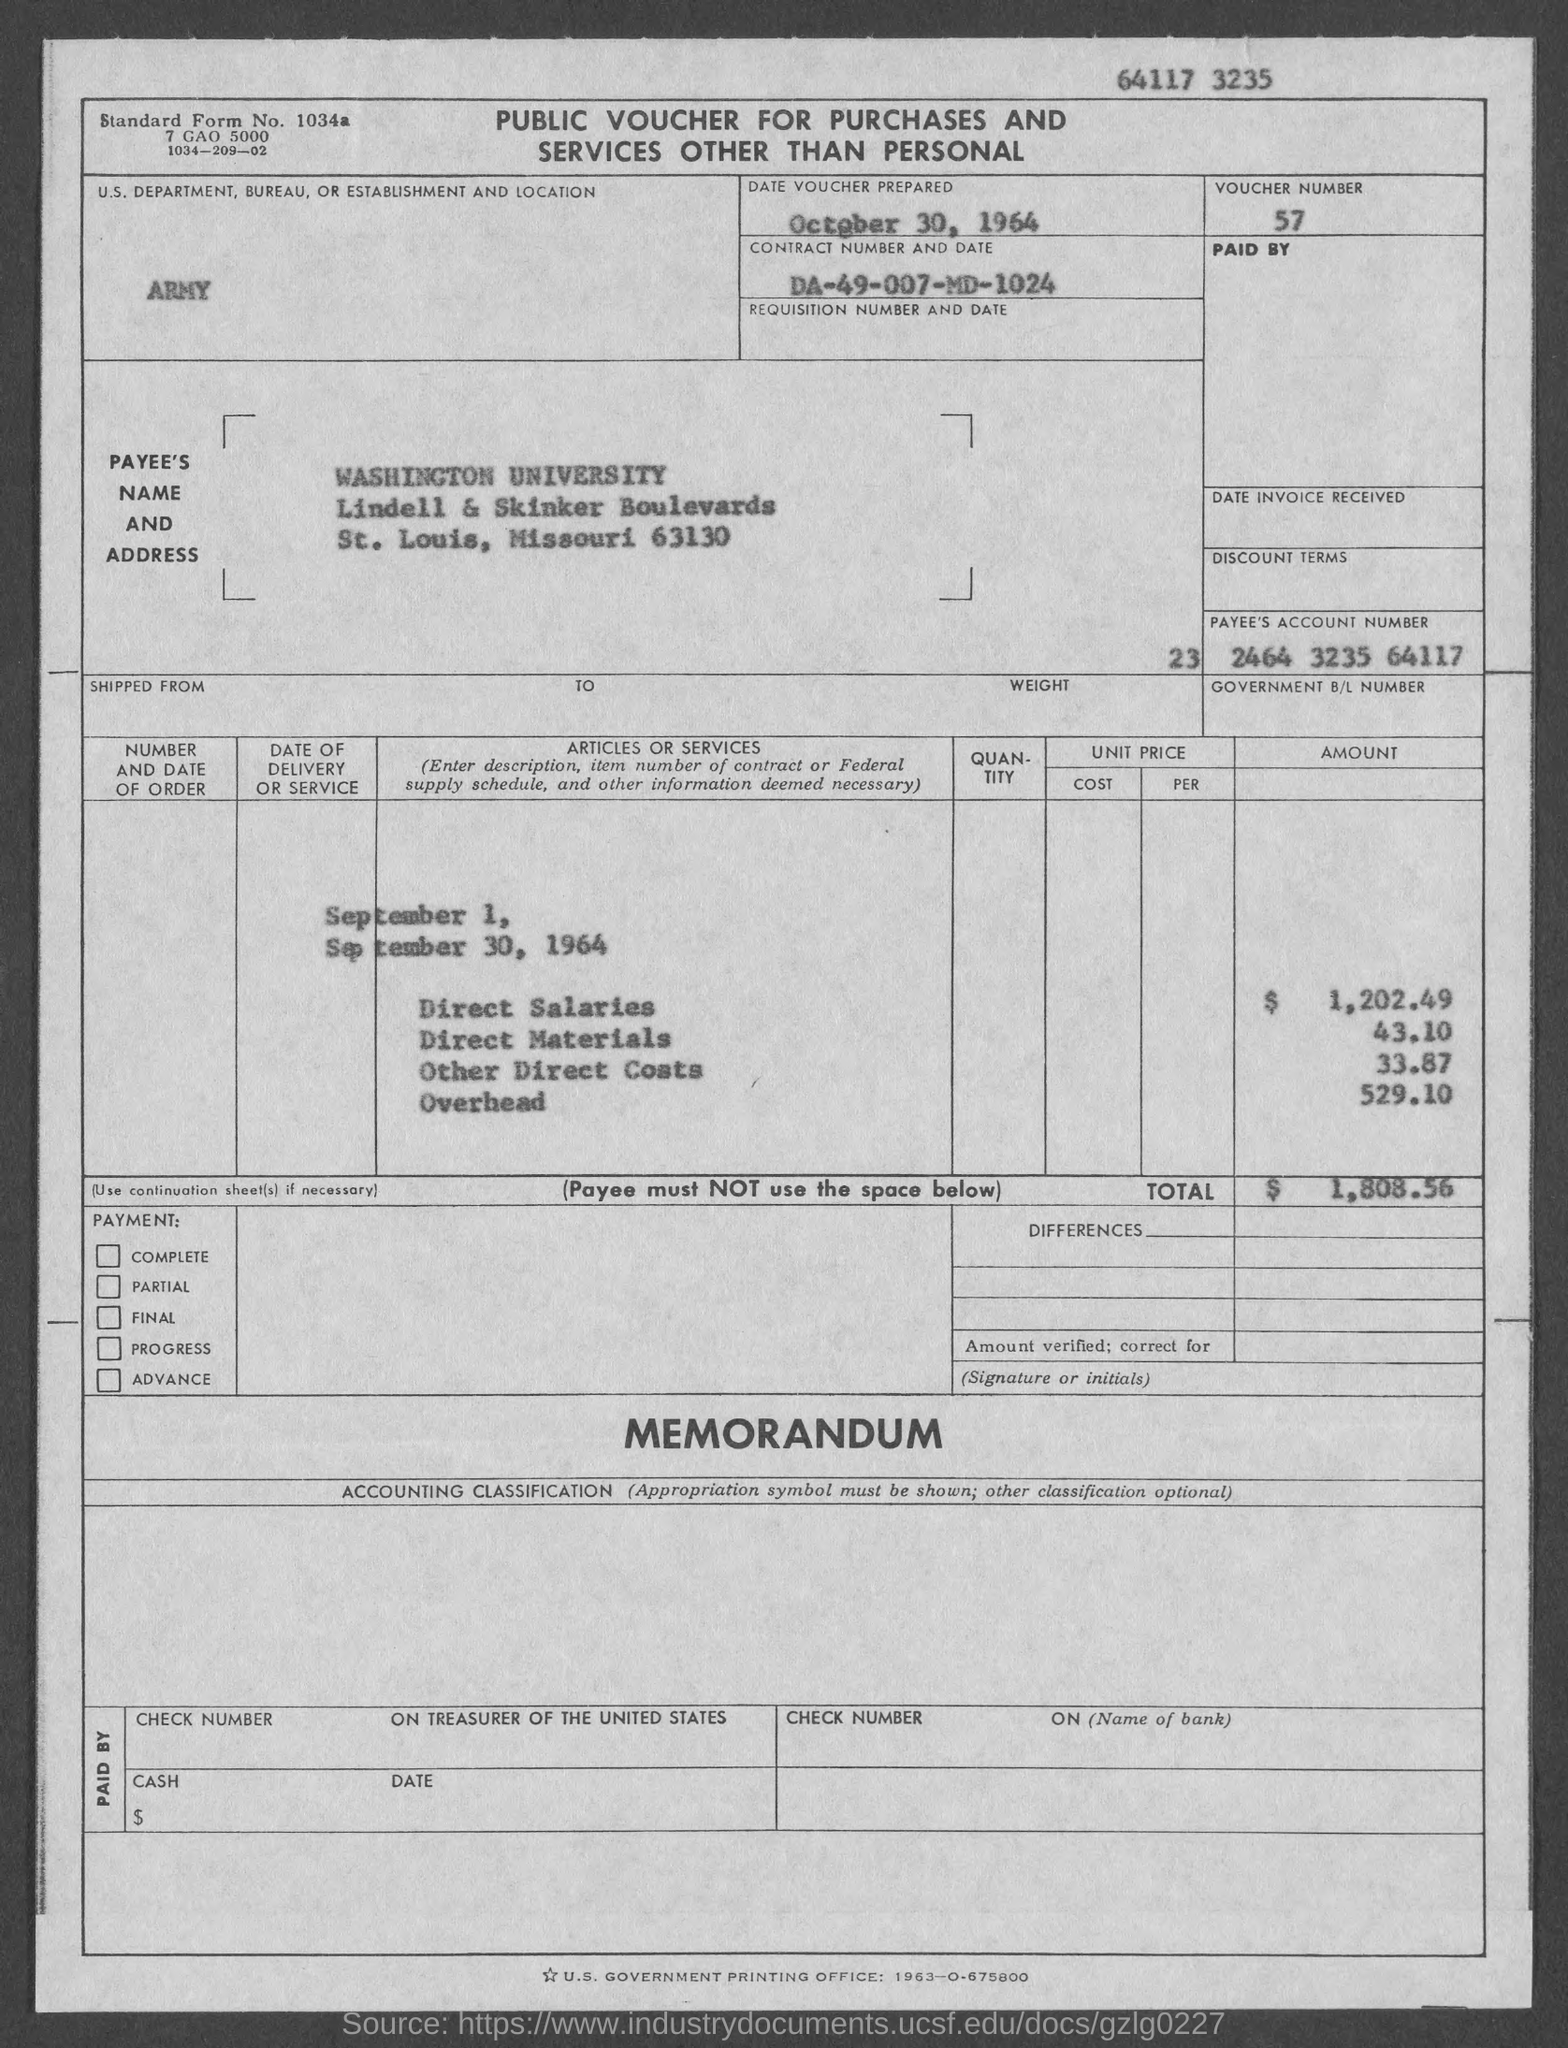What is the voucher no.?
Provide a succinct answer. 57. When is the date voucher is  prepared ?
Your answer should be compact. October 30, 1964. What is the standard form no.?
Keep it short and to the point. 1034a. What is the total amount ?
Give a very brief answer. $1,808.56. What is the us. department, bureau, or establishment in voucher?
Offer a very short reply. Army. What is the payee's name ?
Your response must be concise. Washington university. 